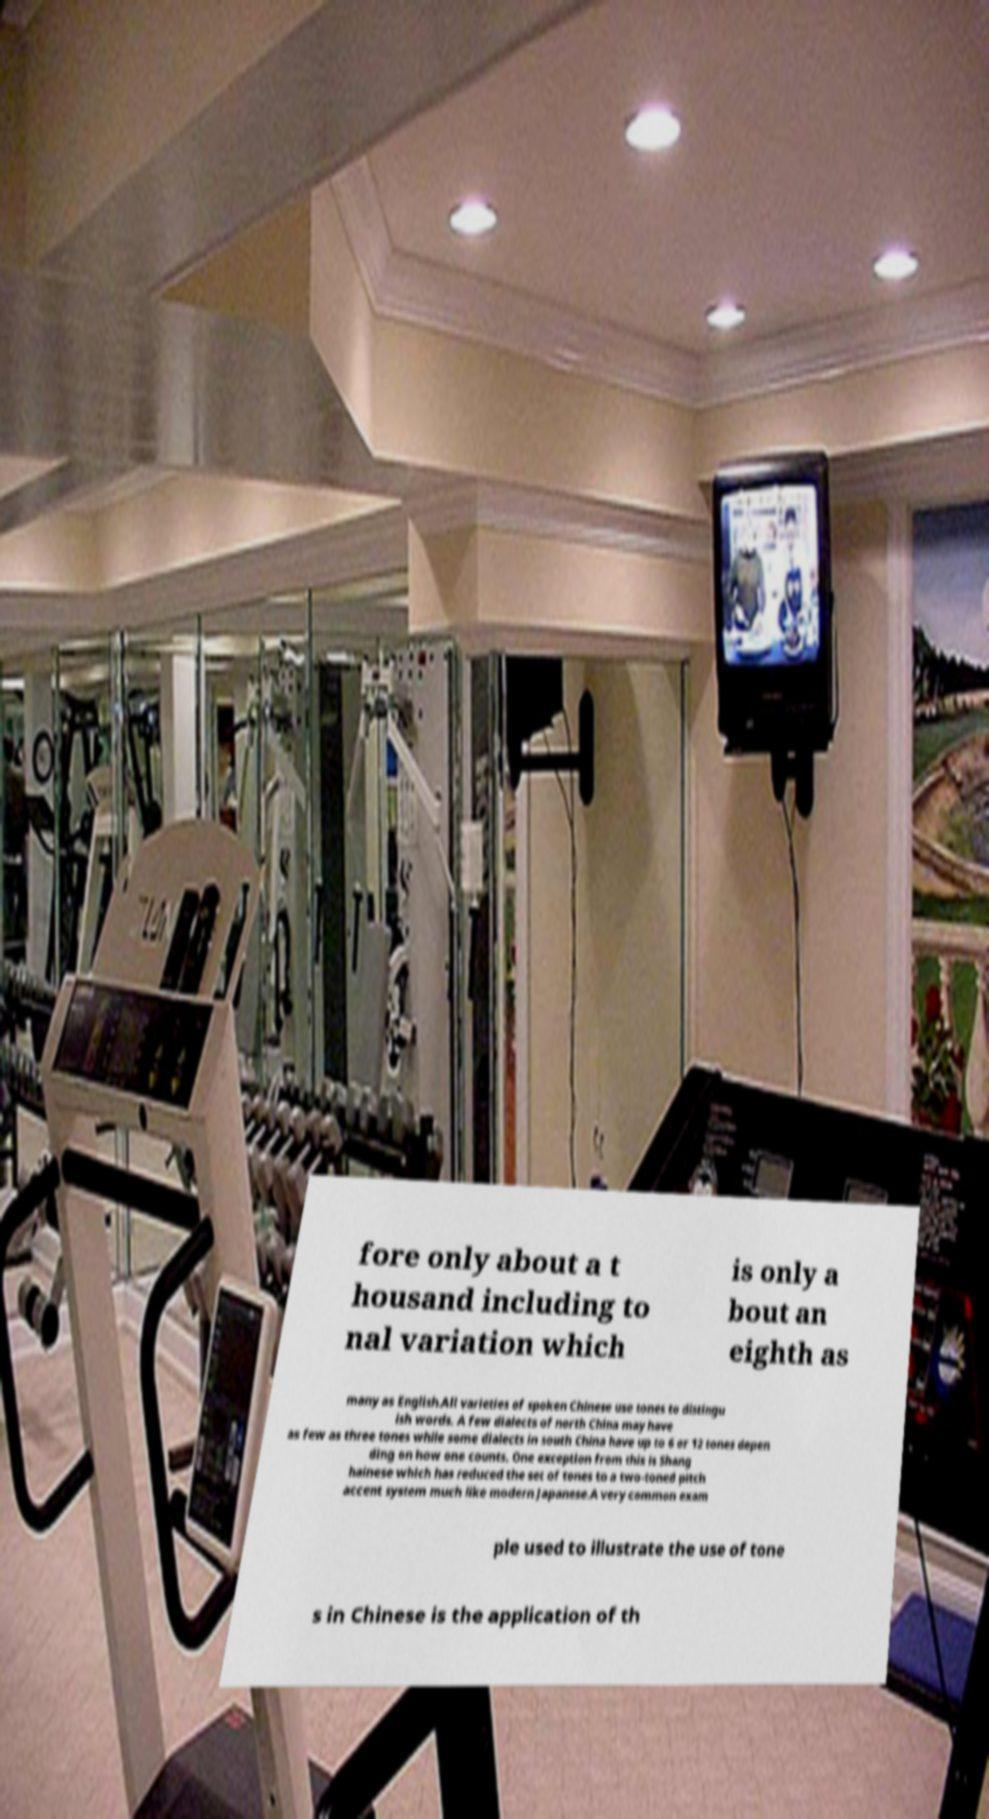Please read and relay the text visible in this image. What does it say? fore only about a t housand including to nal variation which is only a bout an eighth as many as English.All varieties of spoken Chinese use tones to distingu ish words. A few dialects of north China may have as few as three tones while some dialects in south China have up to 6 or 12 tones depen ding on how one counts. One exception from this is Shang hainese which has reduced the set of tones to a two-toned pitch accent system much like modern Japanese.A very common exam ple used to illustrate the use of tone s in Chinese is the application of th 